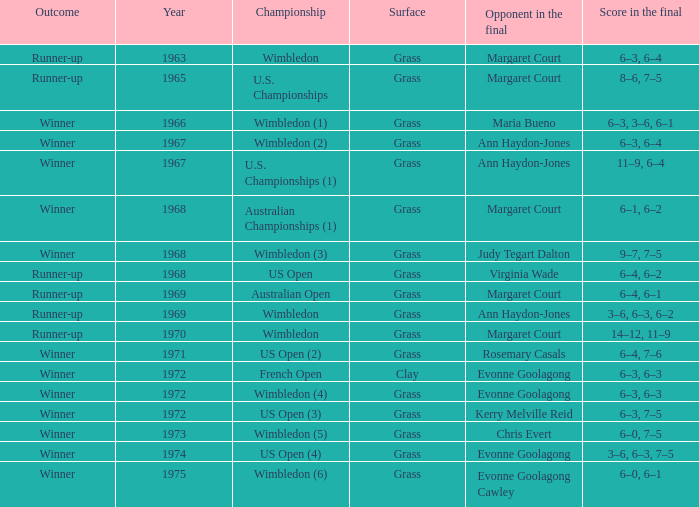What was the final score of the Australian Open? 6–4, 6–1. 